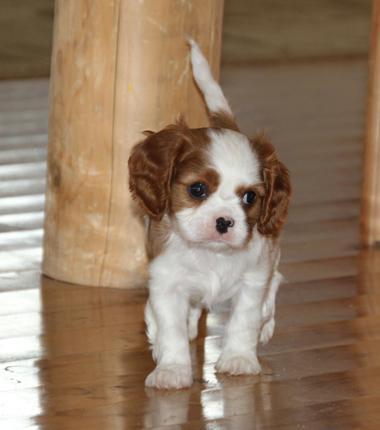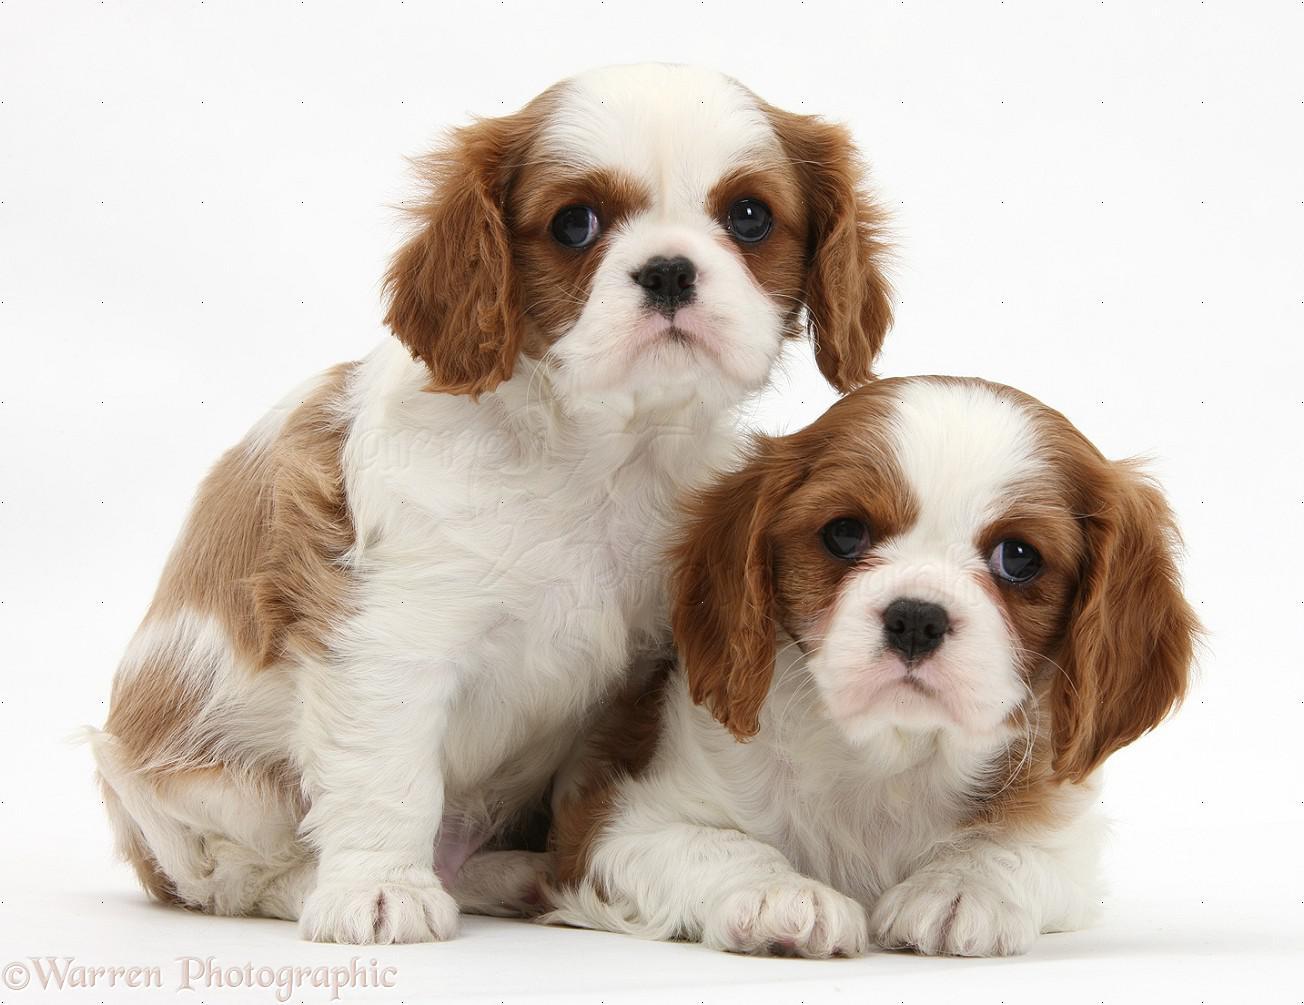The first image is the image on the left, the second image is the image on the right. For the images displayed, is the sentence "There are three dogs" factually correct? Answer yes or no. Yes. 